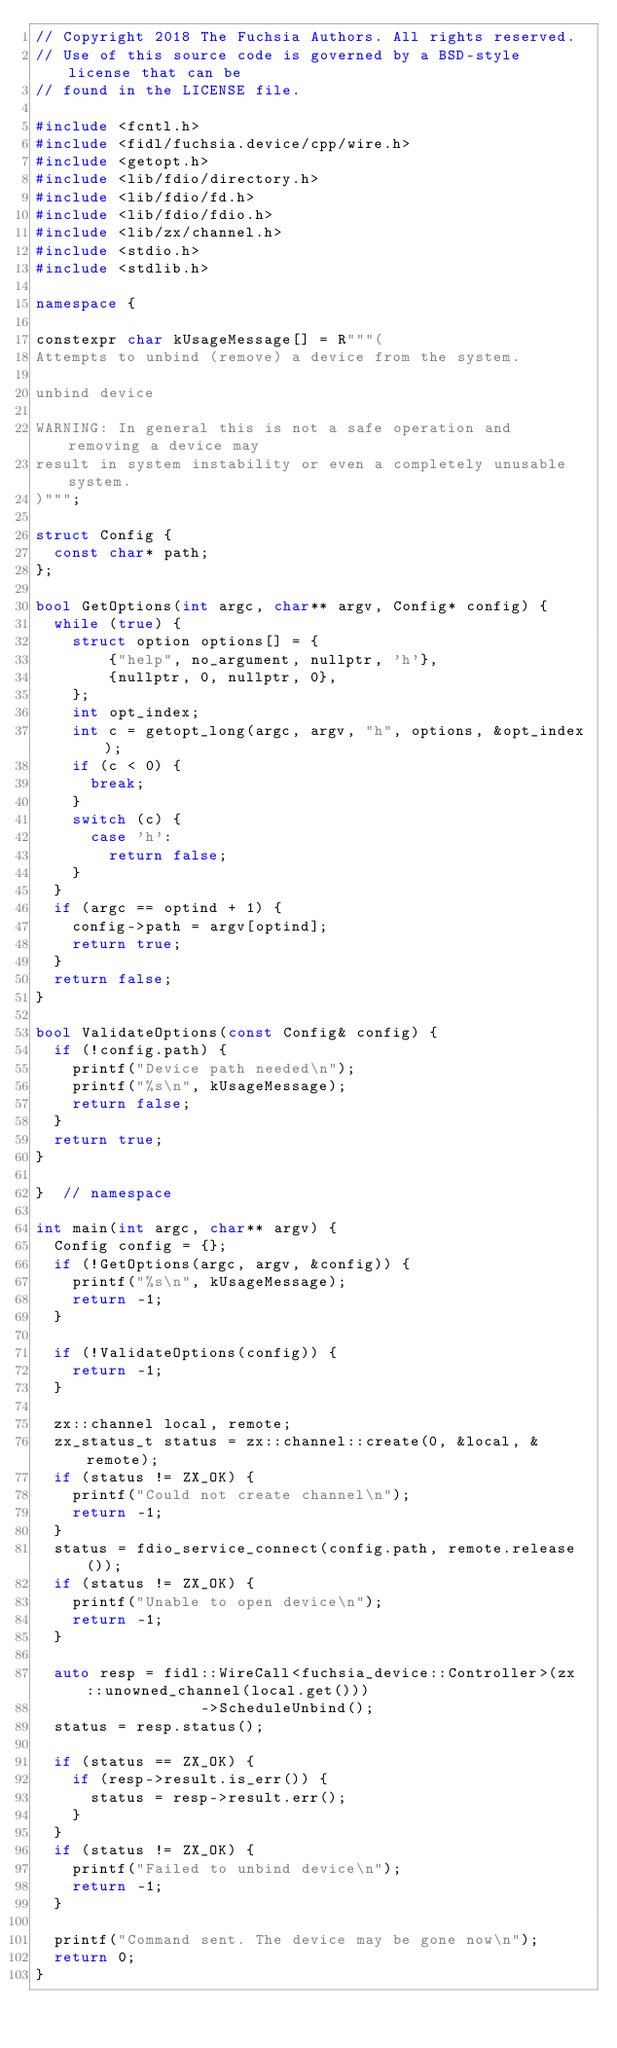Convert code to text. <code><loc_0><loc_0><loc_500><loc_500><_C++_>// Copyright 2018 The Fuchsia Authors. All rights reserved.
// Use of this source code is governed by a BSD-style license that can be
// found in the LICENSE file.

#include <fcntl.h>
#include <fidl/fuchsia.device/cpp/wire.h>
#include <getopt.h>
#include <lib/fdio/directory.h>
#include <lib/fdio/fd.h>
#include <lib/fdio/fdio.h>
#include <lib/zx/channel.h>
#include <stdio.h>
#include <stdlib.h>

namespace {

constexpr char kUsageMessage[] = R"""(
Attempts to unbind (remove) a device from the system.

unbind device

WARNING: In general this is not a safe operation and removing a device may
result in system instability or even a completely unusable system.
)""";

struct Config {
  const char* path;
};

bool GetOptions(int argc, char** argv, Config* config) {
  while (true) {
    struct option options[] = {
        {"help", no_argument, nullptr, 'h'},
        {nullptr, 0, nullptr, 0},
    };
    int opt_index;
    int c = getopt_long(argc, argv, "h", options, &opt_index);
    if (c < 0) {
      break;
    }
    switch (c) {
      case 'h':
        return false;
    }
  }
  if (argc == optind + 1) {
    config->path = argv[optind];
    return true;
  }
  return false;
}

bool ValidateOptions(const Config& config) {
  if (!config.path) {
    printf("Device path needed\n");
    printf("%s\n", kUsageMessage);
    return false;
  }
  return true;
}

}  // namespace

int main(int argc, char** argv) {
  Config config = {};
  if (!GetOptions(argc, argv, &config)) {
    printf("%s\n", kUsageMessage);
    return -1;
  }

  if (!ValidateOptions(config)) {
    return -1;
  }

  zx::channel local, remote;
  zx_status_t status = zx::channel::create(0, &local, &remote);
  if (status != ZX_OK) {
    printf("Could not create channel\n");
    return -1;
  }
  status = fdio_service_connect(config.path, remote.release());
  if (status != ZX_OK) {
    printf("Unable to open device\n");
    return -1;
  }

  auto resp = fidl::WireCall<fuchsia_device::Controller>(zx::unowned_channel(local.get()))
                  ->ScheduleUnbind();
  status = resp.status();

  if (status == ZX_OK) {
    if (resp->result.is_err()) {
      status = resp->result.err();
    }
  }
  if (status != ZX_OK) {
    printf("Failed to unbind device\n");
    return -1;
  }

  printf("Command sent. The device may be gone now\n");
  return 0;
}
</code> 